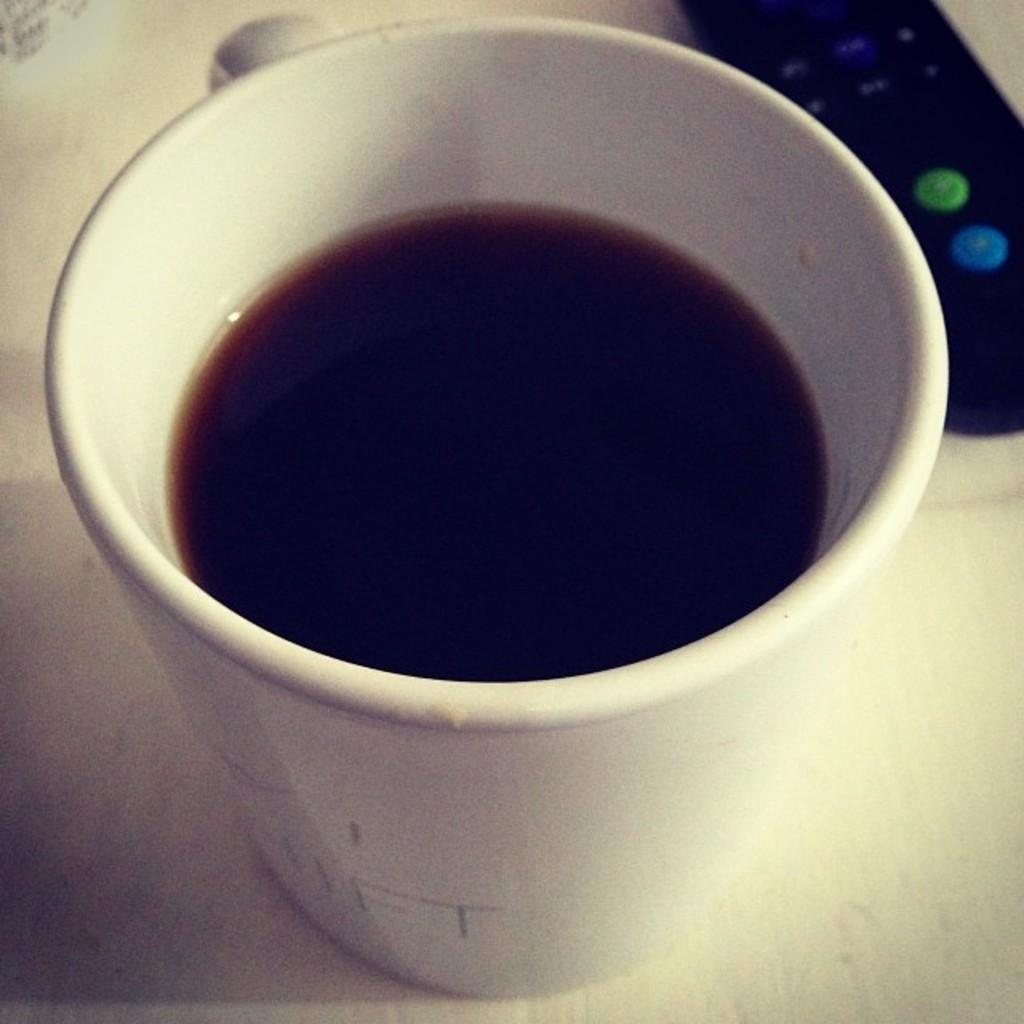What is contained in the cup that is visible in the image? There is a cup with liquid in the image. What other object can be seen in the image? There is a remote on a platform in the image. Can you tell me how many afterthoughts are present at the seashore in the image? There is no mention of afterthoughts or a seashore in the image, so it is not possible to answer that question. 